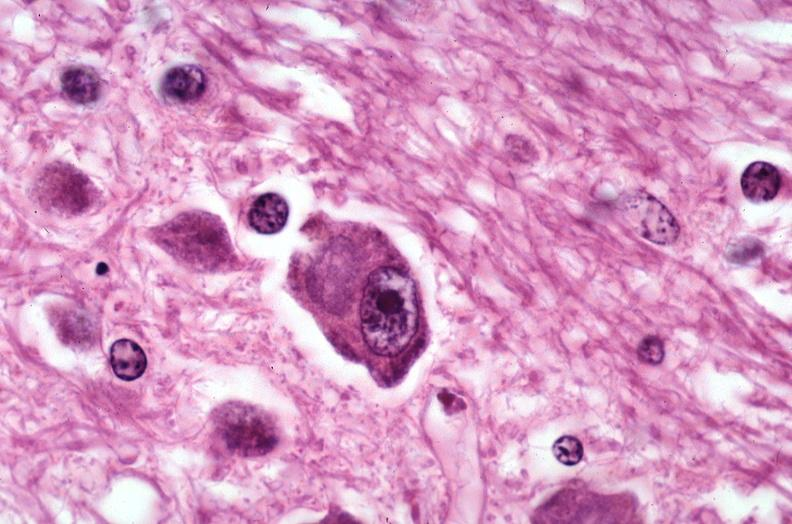does sac show brain, pick 's disease?
Answer the question using a single word or phrase. No 